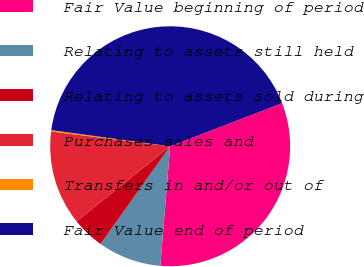Convert chart. <chart><loc_0><loc_0><loc_500><loc_500><pie_chart><fcel>Fair Value beginning of period<fcel>Relating to assets still held<fcel>Relating to assets sold during<fcel>Purchases sales and<fcel>Transfers in and/or out of<fcel>Fair Value end of period<nl><fcel>32.15%<fcel>8.55%<fcel>4.37%<fcel>12.73%<fcel>0.19%<fcel>41.99%<nl></chart> 